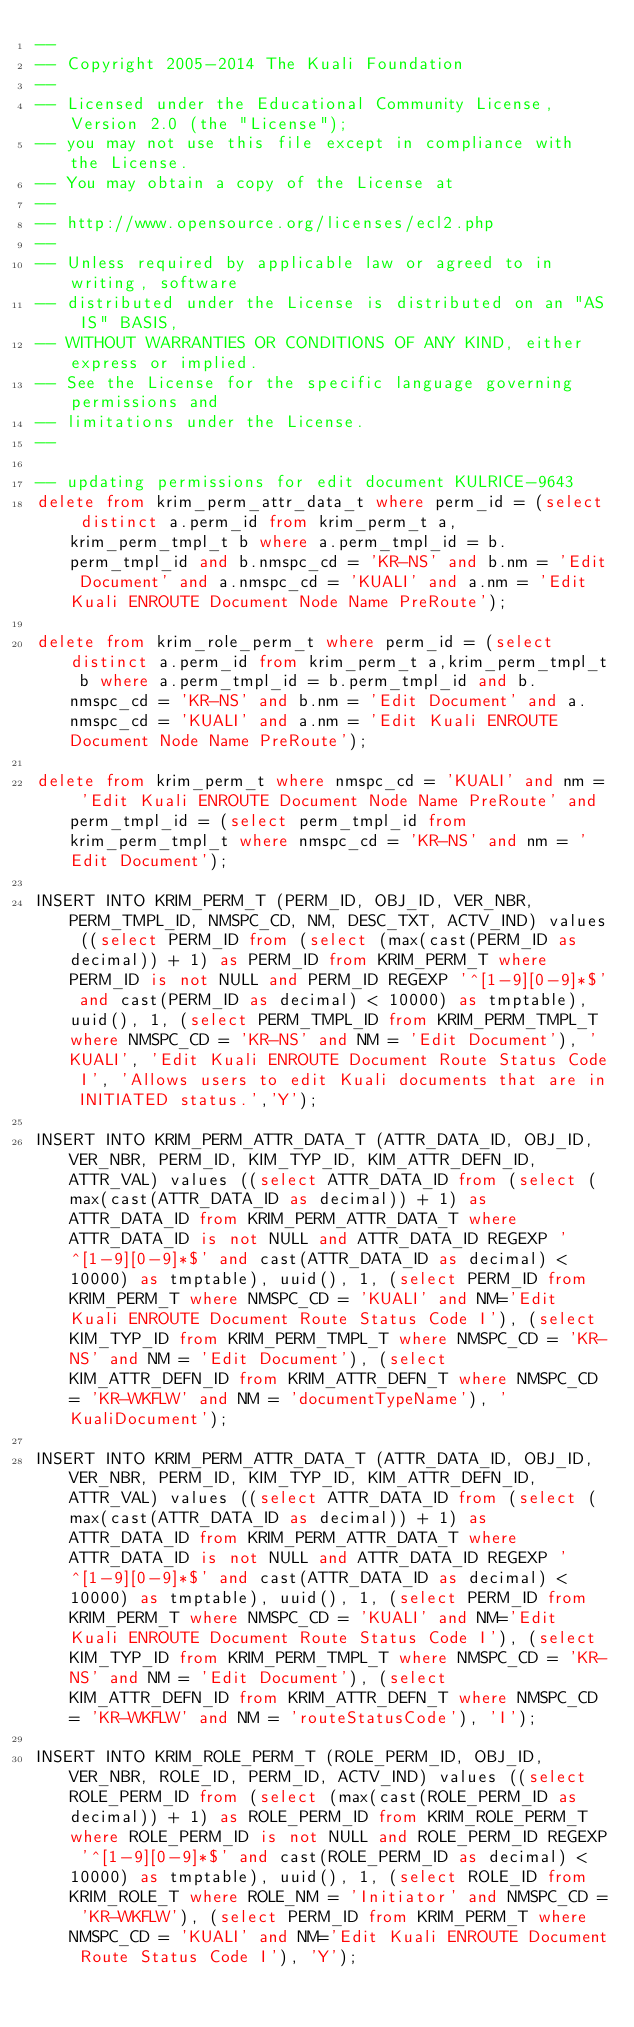Convert code to text. <code><loc_0><loc_0><loc_500><loc_500><_SQL_>--
-- Copyright 2005-2014 The Kuali Foundation
--
-- Licensed under the Educational Community License, Version 2.0 (the "License");
-- you may not use this file except in compliance with the License.
-- You may obtain a copy of the License at
--
-- http://www.opensource.org/licenses/ecl2.php
--
-- Unless required by applicable law or agreed to in writing, software
-- distributed under the License is distributed on an "AS IS" BASIS,
-- WITHOUT WARRANTIES OR CONDITIONS OF ANY KIND, either express or implied.
-- See the License for the specific language governing permissions and
-- limitations under the License.
--

-- updating permissions for edit document KULRICE-9643
delete from krim_perm_attr_data_t where perm_id = (select distinct a.perm_id from krim_perm_t a,krim_perm_tmpl_t b where a.perm_tmpl_id = b.perm_tmpl_id and b.nmspc_cd = 'KR-NS' and b.nm = 'Edit Document' and a.nmspc_cd = 'KUALI' and a.nm = 'Edit Kuali ENROUTE Document Node Name PreRoute');

delete from krim_role_perm_t where perm_id = (select distinct a.perm_id from krim_perm_t a,krim_perm_tmpl_t b where a.perm_tmpl_id = b.perm_tmpl_id and b.nmspc_cd = 'KR-NS' and b.nm = 'Edit Document' and a.nmspc_cd = 'KUALI' and a.nm = 'Edit Kuali ENROUTE Document Node Name PreRoute');

delete from krim_perm_t where nmspc_cd = 'KUALI' and nm = 'Edit Kuali ENROUTE Document Node Name PreRoute' and perm_tmpl_id = (select perm_tmpl_id from krim_perm_tmpl_t where nmspc_cd = 'KR-NS' and nm = 'Edit Document');

INSERT INTO KRIM_PERM_T (PERM_ID, OBJ_ID, VER_NBR, PERM_TMPL_ID, NMSPC_CD, NM, DESC_TXT, ACTV_IND) values ((select PERM_ID from (select (max(cast(PERM_ID as decimal)) + 1) as PERM_ID from KRIM_PERM_T where PERM_ID is not NULL and PERM_ID REGEXP '^[1-9][0-9]*$' and cast(PERM_ID as decimal) < 10000) as tmptable), uuid(), 1, (select PERM_TMPL_ID from KRIM_PERM_TMPL_T where NMSPC_CD = 'KR-NS' and NM = 'Edit Document'), 'KUALI', 'Edit Kuali ENROUTE Document Route Status Code I', 'Allows users to edit Kuali documents that are in INITIATED status.','Y');

INSERT INTO KRIM_PERM_ATTR_DATA_T (ATTR_DATA_ID, OBJ_ID, VER_NBR, PERM_ID, KIM_TYP_ID, KIM_ATTR_DEFN_ID, ATTR_VAL) values ((select ATTR_DATA_ID from (select (max(cast(ATTR_DATA_ID as decimal)) + 1) as ATTR_DATA_ID from KRIM_PERM_ATTR_DATA_T where ATTR_DATA_ID is not NULL and ATTR_DATA_ID REGEXP '^[1-9][0-9]*$' and cast(ATTR_DATA_ID as decimal) < 10000) as tmptable), uuid(), 1, (select PERM_ID from KRIM_PERM_T where NMSPC_CD = 'KUALI' and NM='Edit Kuali ENROUTE Document Route Status Code I'), (select KIM_TYP_ID from KRIM_PERM_TMPL_T where NMSPC_CD = 'KR-NS' and NM = 'Edit Document'), (select KIM_ATTR_DEFN_ID from KRIM_ATTR_DEFN_T where NMSPC_CD = 'KR-WKFLW' and NM = 'documentTypeName'), 'KualiDocument');

INSERT INTO KRIM_PERM_ATTR_DATA_T (ATTR_DATA_ID, OBJ_ID, VER_NBR, PERM_ID, KIM_TYP_ID, KIM_ATTR_DEFN_ID, ATTR_VAL) values ((select ATTR_DATA_ID from (select (max(cast(ATTR_DATA_ID as decimal)) + 1) as ATTR_DATA_ID from KRIM_PERM_ATTR_DATA_T where ATTR_DATA_ID is not NULL and ATTR_DATA_ID REGEXP '^[1-9][0-9]*$' and cast(ATTR_DATA_ID as decimal) < 10000) as tmptable), uuid(), 1, (select PERM_ID from KRIM_PERM_T where NMSPC_CD = 'KUALI' and NM='Edit Kuali ENROUTE Document Route Status Code I'), (select KIM_TYP_ID from KRIM_PERM_TMPL_T where NMSPC_CD = 'KR-NS' and NM = 'Edit Document'), (select KIM_ATTR_DEFN_ID from KRIM_ATTR_DEFN_T where NMSPC_CD = 'KR-WKFLW' and NM = 'routeStatusCode'), 'I');

INSERT INTO KRIM_ROLE_PERM_T (ROLE_PERM_ID, OBJ_ID, VER_NBR, ROLE_ID, PERM_ID, ACTV_IND) values ((select ROLE_PERM_ID from (select (max(cast(ROLE_PERM_ID as decimal)) + 1) as ROLE_PERM_ID from KRIM_ROLE_PERM_T where ROLE_PERM_ID is not NULL and ROLE_PERM_ID REGEXP '^[1-9][0-9]*$' and cast(ROLE_PERM_ID as decimal) < 10000) as tmptable), uuid(), 1, (select ROLE_ID from KRIM_ROLE_T where ROLE_NM = 'Initiator' and NMSPC_CD = 'KR-WKFLW'), (select PERM_ID from KRIM_PERM_T where NMSPC_CD = 'KUALI' and NM='Edit Kuali ENROUTE Document Route Status Code I'), 'Y');
</code> 